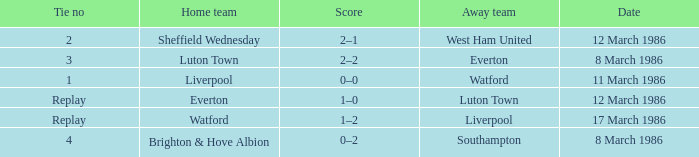What was the tie resulting from Sheffield Wednesday's game? 2.0. 